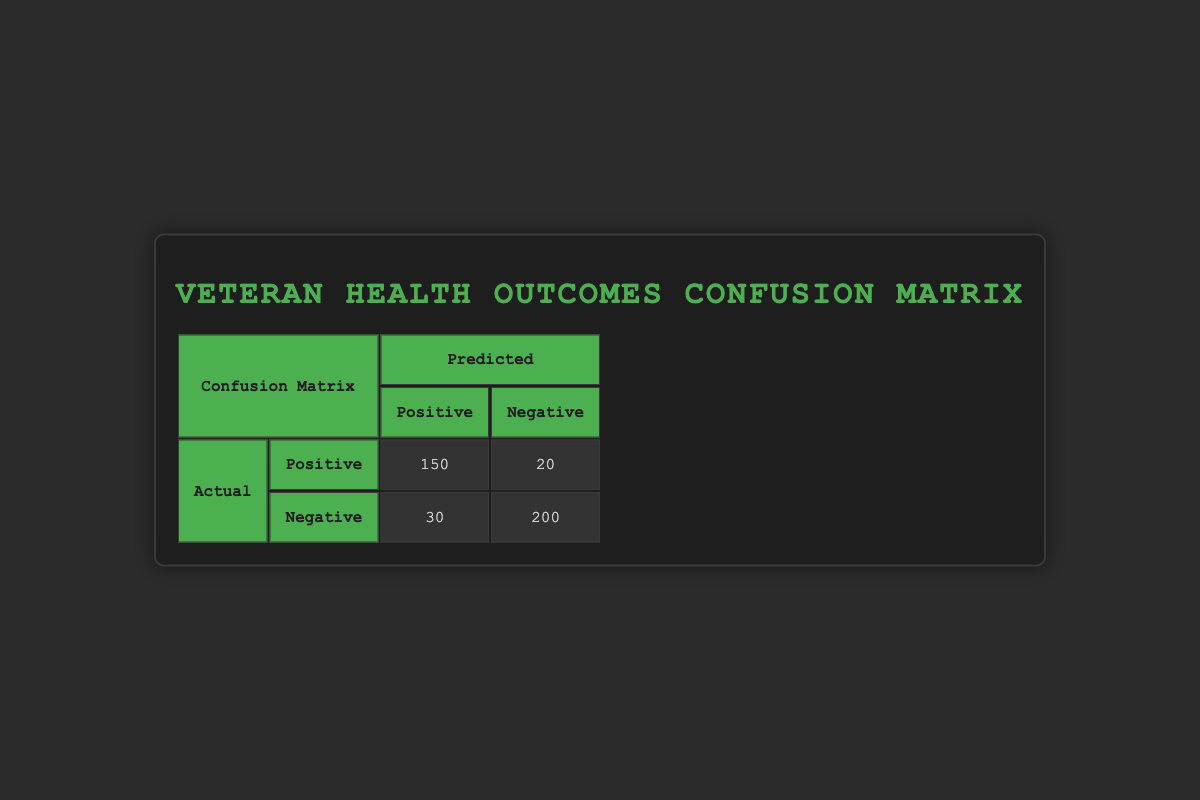What is the total number of true positives? The table shows that the true positive count is 150, directly specified in the confusion matrix.
Answer: 150 What is the total number of false negatives? The table indicates that the false negative count is 20, which is listed under the confusion matrix.
Answer: 20 How many instances of Major Depressive Disorder were predicted as negative but actually were positive? The table reveals that there were 10 instances where Major Depressive Disorder was predicted as negative but was actually positive. This is found in the row for Major Depressive Disorder, where "predicted: No" and "actual: Yes" are shown.
Answer: 10 What is the sum of true positives and false negatives? The true positives count is 150, and the false negatives count is 20. Summing these values gives us 150 + 20 = 170.
Answer: 170 Is the number of false positives greater than the number of true negatives? From the table, the false positive count is 30 and the true negative count is 200. Since 30 is not greater than 200, the statement is false.
Answer: No How many total actual positive cases of Anxiety Disorder were there? The Anxiety Disorder row has 70 instances predicted as positive (which are true positives) and 5 instances predicted as negative (which are false negatives). Therefore, total actual cases equal 70 + 5 = 75.
Answer: 75 What percentage of true positives are there compared to the total number of positive predictions? The total number of positive predictions equals true positives plus false positives (150 + 30 = 180). To find the percentage of true positives, divide the true positives (150) by total positive predictions (180) and multiply by 100: (150 / 180) × 100 = 83.33%.
Answer: 83.33% What is the ratio of false negatives to true negatives? The false negatives are 20, and the true negatives are 200. To find the ratio, divide false negatives by true negatives: 20:200 reduces to 1:10.
Answer: 1:10 How many instances were predicted as having Substance Use Disorder that actually did not? The table specifies that there were 10 instances predicted as having Substance Use Disorder but were actually negative. This is indicated in the row where "predicted: Yes" and "actual: No" are listed.
Answer: 10 